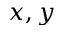<formula> <loc_0><loc_0><loc_500><loc_500>x , y</formula> 